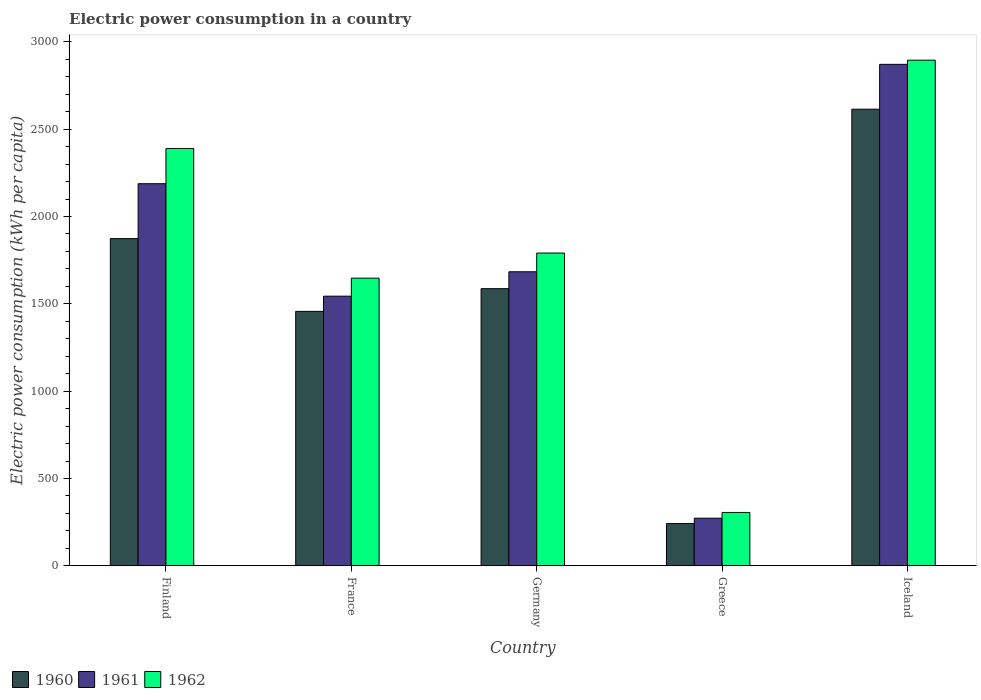How many groups of bars are there?
Offer a terse response. 5. Are the number of bars per tick equal to the number of legend labels?
Give a very brief answer. Yes. How many bars are there on the 4th tick from the right?
Keep it short and to the point. 3. What is the label of the 2nd group of bars from the left?
Give a very brief answer. France. In how many cases, is the number of bars for a given country not equal to the number of legend labels?
Your response must be concise. 0. What is the electric power consumption in in 1961 in Greece?
Your answer should be compact. 272.56. Across all countries, what is the maximum electric power consumption in in 1962?
Give a very brief answer. 2895.09. Across all countries, what is the minimum electric power consumption in in 1962?
Offer a terse response. 305.39. In which country was the electric power consumption in in 1960 maximum?
Keep it short and to the point. Iceland. In which country was the electric power consumption in in 1960 minimum?
Your answer should be compact. Greece. What is the total electric power consumption in in 1961 in the graph?
Offer a very short reply. 8558.36. What is the difference between the electric power consumption in in 1961 in Greece and that in Iceland?
Provide a short and direct response. -2598.48. What is the difference between the electric power consumption in in 1961 in France and the electric power consumption in in 1962 in Finland?
Keep it short and to the point. -845.5. What is the average electric power consumption in in 1962 per country?
Offer a very short reply. 1805.44. What is the difference between the electric power consumption in of/in 1961 and electric power consumption in of/in 1960 in Greece?
Your response must be concise. 30.84. What is the ratio of the electric power consumption in in 1961 in France to that in Germany?
Provide a succinct answer. 0.92. Is the electric power consumption in in 1961 in Germany less than that in Greece?
Make the answer very short. No. Is the difference between the electric power consumption in in 1961 in Germany and Iceland greater than the difference between the electric power consumption in in 1960 in Germany and Iceland?
Ensure brevity in your answer.  No. What is the difference between the highest and the second highest electric power consumption in in 1962?
Provide a succinct answer. 598.52. What is the difference between the highest and the lowest electric power consumption in in 1961?
Your answer should be compact. 2598.48. Is the sum of the electric power consumption in in 1962 in Greece and Iceland greater than the maximum electric power consumption in in 1960 across all countries?
Give a very brief answer. Yes. What does the 2nd bar from the right in Iceland represents?
Your response must be concise. 1961. How many bars are there?
Ensure brevity in your answer.  15. What is the difference between two consecutive major ticks on the Y-axis?
Your answer should be compact. 500. Does the graph contain any zero values?
Ensure brevity in your answer.  No. Does the graph contain grids?
Your answer should be compact. No. Where does the legend appear in the graph?
Your response must be concise. Bottom left. How many legend labels are there?
Provide a succinct answer. 3. How are the legend labels stacked?
Your response must be concise. Horizontal. What is the title of the graph?
Offer a terse response. Electric power consumption in a country. Does "1974" appear as one of the legend labels in the graph?
Provide a short and direct response. No. What is the label or title of the X-axis?
Keep it short and to the point. Country. What is the label or title of the Y-axis?
Your answer should be compact. Electric power consumption (kWh per capita). What is the Electric power consumption (kWh per capita) in 1960 in Finland?
Ensure brevity in your answer.  1873.29. What is the Electric power consumption (kWh per capita) in 1961 in Finland?
Your answer should be very brief. 2187.62. What is the Electric power consumption (kWh per capita) in 1962 in Finland?
Make the answer very short. 2389.21. What is the Electric power consumption (kWh per capita) of 1960 in France?
Provide a short and direct response. 1456.69. What is the Electric power consumption (kWh per capita) in 1961 in France?
Make the answer very short. 1543.71. What is the Electric power consumption (kWh per capita) in 1962 in France?
Provide a succinct answer. 1646.83. What is the Electric power consumption (kWh per capita) of 1960 in Germany?
Make the answer very short. 1586.75. What is the Electric power consumption (kWh per capita) of 1961 in Germany?
Provide a short and direct response. 1683.41. What is the Electric power consumption (kWh per capita) in 1962 in Germany?
Your response must be concise. 1790.69. What is the Electric power consumption (kWh per capita) in 1960 in Greece?
Your answer should be very brief. 241.73. What is the Electric power consumption (kWh per capita) in 1961 in Greece?
Your answer should be compact. 272.56. What is the Electric power consumption (kWh per capita) of 1962 in Greece?
Ensure brevity in your answer.  305.39. What is the Electric power consumption (kWh per capita) of 1960 in Iceland?
Give a very brief answer. 2614.28. What is the Electric power consumption (kWh per capita) of 1961 in Iceland?
Provide a succinct answer. 2871.04. What is the Electric power consumption (kWh per capita) of 1962 in Iceland?
Offer a terse response. 2895.09. Across all countries, what is the maximum Electric power consumption (kWh per capita) in 1960?
Provide a succinct answer. 2614.28. Across all countries, what is the maximum Electric power consumption (kWh per capita) in 1961?
Provide a short and direct response. 2871.04. Across all countries, what is the maximum Electric power consumption (kWh per capita) in 1962?
Give a very brief answer. 2895.09. Across all countries, what is the minimum Electric power consumption (kWh per capita) in 1960?
Offer a very short reply. 241.73. Across all countries, what is the minimum Electric power consumption (kWh per capita) of 1961?
Your answer should be very brief. 272.56. Across all countries, what is the minimum Electric power consumption (kWh per capita) of 1962?
Your answer should be very brief. 305.39. What is the total Electric power consumption (kWh per capita) of 1960 in the graph?
Offer a terse response. 7772.74. What is the total Electric power consumption (kWh per capita) of 1961 in the graph?
Your answer should be compact. 8558.36. What is the total Electric power consumption (kWh per capita) in 1962 in the graph?
Keep it short and to the point. 9027.2. What is the difference between the Electric power consumption (kWh per capita) in 1960 in Finland and that in France?
Provide a short and direct response. 416.6. What is the difference between the Electric power consumption (kWh per capita) in 1961 in Finland and that in France?
Ensure brevity in your answer.  643.91. What is the difference between the Electric power consumption (kWh per capita) of 1962 in Finland and that in France?
Your answer should be compact. 742.38. What is the difference between the Electric power consumption (kWh per capita) in 1960 in Finland and that in Germany?
Give a very brief answer. 286.54. What is the difference between the Electric power consumption (kWh per capita) of 1961 in Finland and that in Germany?
Keep it short and to the point. 504.21. What is the difference between the Electric power consumption (kWh per capita) in 1962 in Finland and that in Germany?
Offer a terse response. 598.52. What is the difference between the Electric power consumption (kWh per capita) in 1960 in Finland and that in Greece?
Your response must be concise. 1631.57. What is the difference between the Electric power consumption (kWh per capita) in 1961 in Finland and that in Greece?
Your response must be concise. 1915.06. What is the difference between the Electric power consumption (kWh per capita) of 1962 in Finland and that in Greece?
Your answer should be very brief. 2083.82. What is the difference between the Electric power consumption (kWh per capita) in 1960 in Finland and that in Iceland?
Keep it short and to the point. -740.99. What is the difference between the Electric power consumption (kWh per capita) of 1961 in Finland and that in Iceland?
Keep it short and to the point. -683.42. What is the difference between the Electric power consumption (kWh per capita) of 1962 in Finland and that in Iceland?
Your answer should be very brief. -505.88. What is the difference between the Electric power consumption (kWh per capita) in 1960 in France and that in Germany?
Keep it short and to the point. -130.06. What is the difference between the Electric power consumption (kWh per capita) of 1961 in France and that in Germany?
Offer a very short reply. -139.7. What is the difference between the Electric power consumption (kWh per capita) in 1962 in France and that in Germany?
Give a very brief answer. -143.85. What is the difference between the Electric power consumption (kWh per capita) in 1960 in France and that in Greece?
Your response must be concise. 1214.97. What is the difference between the Electric power consumption (kWh per capita) in 1961 in France and that in Greece?
Offer a very short reply. 1271.15. What is the difference between the Electric power consumption (kWh per capita) in 1962 in France and that in Greece?
Ensure brevity in your answer.  1341.44. What is the difference between the Electric power consumption (kWh per capita) of 1960 in France and that in Iceland?
Keep it short and to the point. -1157.59. What is the difference between the Electric power consumption (kWh per capita) of 1961 in France and that in Iceland?
Provide a short and direct response. -1327.33. What is the difference between the Electric power consumption (kWh per capita) of 1962 in France and that in Iceland?
Provide a short and direct response. -1248.25. What is the difference between the Electric power consumption (kWh per capita) of 1960 in Germany and that in Greece?
Offer a terse response. 1345.02. What is the difference between the Electric power consumption (kWh per capita) in 1961 in Germany and that in Greece?
Give a very brief answer. 1410.85. What is the difference between the Electric power consumption (kWh per capita) in 1962 in Germany and that in Greece?
Provide a short and direct response. 1485.3. What is the difference between the Electric power consumption (kWh per capita) of 1960 in Germany and that in Iceland?
Make the answer very short. -1027.53. What is the difference between the Electric power consumption (kWh per capita) of 1961 in Germany and that in Iceland?
Your response must be concise. -1187.63. What is the difference between the Electric power consumption (kWh per capita) in 1962 in Germany and that in Iceland?
Ensure brevity in your answer.  -1104.4. What is the difference between the Electric power consumption (kWh per capita) in 1960 in Greece and that in Iceland?
Make the answer very short. -2372.56. What is the difference between the Electric power consumption (kWh per capita) in 1961 in Greece and that in Iceland?
Your answer should be compact. -2598.48. What is the difference between the Electric power consumption (kWh per capita) in 1962 in Greece and that in Iceland?
Offer a very short reply. -2589.7. What is the difference between the Electric power consumption (kWh per capita) in 1960 in Finland and the Electric power consumption (kWh per capita) in 1961 in France?
Your answer should be compact. 329.58. What is the difference between the Electric power consumption (kWh per capita) in 1960 in Finland and the Electric power consumption (kWh per capita) in 1962 in France?
Ensure brevity in your answer.  226.46. What is the difference between the Electric power consumption (kWh per capita) of 1961 in Finland and the Electric power consumption (kWh per capita) of 1962 in France?
Provide a succinct answer. 540.79. What is the difference between the Electric power consumption (kWh per capita) in 1960 in Finland and the Electric power consumption (kWh per capita) in 1961 in Germany?
Offer a terse response. 189.88. What is the difference between the Electric power consumption (kWh per capita) in 1960 in Finland and the Electric power consumption (kWh per capita) in 1962 in Germany?
Provide a short and direct response. 82.61. What is the difference between the Electric power consumption (kWh per capita) of 1961 in Finland and the Electric power consumption (kWh per capita) of 1962 in Germany?
Keep it short and to the point. 396.94. What is the difference between the Electric power consumption (kWh per capita) of 1960 in Finland and the Electric power consumption (kWh per capita) of 1961 in Greece?
Ensure brevity in your answer.  1600.73. What is the difference between the Electric power consumption (kWh per capita) of 1960 in Finland and the Electric power consumption (kWh per capita) of 1962 in Greece?
Give a very brief answer. 1567.9. What is the difference between the Electric power consumption (kWh per capita) in 1961 in Finland and the Electric power consumption (kWh per capita) in 1962 in Greece?
Ensure brevity in your answer.  1882.23. What is the difference between the Electric power consumption (kWh per capita) in 1960 in Finland and the Electric power consumption (kWh per capita) in 1961 in Iceland?
Offer a very short reply. -997.75. What is the difference between the Electric power consumption (kWh per capita) of 1960 in Finland and the Electric power consumption (kWh per capita) of 1962 in Iceland?
Offer a terse response. -1021.79. What is the difference between the Electric power consumption (kWh per capita) in 1961 in Finland and the Electric power consumption (kWh per capita) in 1962 in Iceland?
Make the answer very short. -707.46. What is the difference between the Electric power consumption (kWh per capita) in 1960 in France and the Electric power consumption (kWh per capita) in 1961 in Germany?
Your answer should be very brief. -226.72. What is the difference between the Electric power consumption (kWh per capita) in 1960 in France and the Electric power consumption (kWh per capita) in 1962 in Germany?
Your answer should be very brief. -333.99. What is the difference between the Electric power consumption (kWh per capita) in 1961 in France and the Electric power consumption (kWh per capita) in 1962 in Germany?
Keep it short and to the point. -246.98. What is the difference between the Electric power consumption (kWh per capita) of 1960 in France and the Electric power consumption (kWh per capita) of 1961 in Greece?
Your answer should be compact. 1184.13. What is the difference between the Electric power consumption (kWh per capita) of 1960 in France and the Electric power consumption (kWh per capita) of 1962 in Greece?
Keep it short and to the point. 1151.3. What is the difference between the Electric power consumption (kWh per capita) in 1961 in France and the Electric power consumption (kWh per capita) in 1962 in Greece?
Give a very brief answer. 1238.32. What is the difference between the Electric power consumption (kWh per capita) of 1960 in France and the Electric power consumption (kWh per capita) of 1961 in Iceland?
Provide a succinct answer. -1414.35. What is the difference between the Electric power consumption (kWh per capita) of 1960 in France and the Electric power consumption (kWh per capita) of 1962 in Iceland?
Provide a succinct answer. -1438.39. What is the difference between the Electric power consumption (kWh per capita) in 1961 in France and the Electric power consumption (kWh per capita) in 1962 in Iceland?
Your answer should be very brief. -1351.37. What is the difference between the Electric power consumption (kWh per capita) in 1960 in Germany and the Electric power consumption (kWh per capita) in 1961 in Greece?
Your answer should be compact. 1314.19. What is the difference between the Electric power consumption (kWh per capita) in 1960 in Germany and the Electric power consumption (kWh per capita) in 1962 in Greece?
Give a very brief answer. 1281.36. What is the difference between the Electric power consumption (kWh per capita) of 1961 in Germany and the Electric power consumption (kWh per capita) of 1962 in Greece?
Provide a short and direct response. 1378.03. What is the difference between the Electric power consumption (kWh per capita) of 1960 in Germany and the Electric power consumption (kWh per capita) of 1961 in Iceland?
Make the answer very short. -1284.29. What is the difference between the Electric power consumption (kWh per capita) of 1960 in Germany and the Electric power consumption (kWh per capita) of 1962 in Iceland?
Make the answer very short. -1308.34. What is the difference between the Electric power consumption (kWh per capita) of 1961 in Germany and the Electric power consumption (kWh per capita) of 1962 in Iceland?
Your response must be concise. -1211.67. What is the difference between the Electric power consumption (kWh per capita) in 1960 in Greece and the Electric power consumption (kWh per capita) in 1961 in Iceland?
Offer a terse response. -2629.32. What is the difference between the Electric power consumption (kWh per capita) of 1960 in Greece and the Electric power consumption (kWh per capita) of 1962 in Iceland?
Provide a short and direct response. -2653.36. What is the difference between the Electric power consumption (kWh per capita) of 1961 in Greece and the Electric power consumption (kWh per capita) of 1962 in Iceland?
Keep it short and to the point. -2622.52. What is the average Electric power consumption (kWh per capita) in 1960 per country?
Give a very brief answer. 1554.55. What is the average Electric power consumption (kWh per capita) of 1961 per country?
Offer a terse response. 1711.67. What is the average Electric power consumption (kWh per capita) of 1962 per country?
Your response must be concise. 1805.44. What is the difference between the Electric power consumption (kWh per capita) of 1960 and Electric power consumption (kWh per capita) of 1961 in Finland?
Your response must be concise. -314.33. What is the difference between the Electric power consumption (kWh per capita) of 1960 and Electric power consumption (kWh per capita) of 1962 in Finland?
Offer a very short reply. -515.92. What is the difference between the Electric power consumption (kWh per capita) in 1961 and Electric power consumption (kWh per capita) in 1962 in Finland?
Your answer should be compact. -201.59. What is the difference between the Electric power consumption (kWh per capita) in 1960 and Electric power consumption (kWh per capita) in 1961 in France?
Your answer should be compact. -87.02. What is the difference between the Electric power consumption (kWh per capita) in 1960 and Electric power consumption (kWh per capita) in 1962 in France?
Offer a very short reply. -190.14. What is the difference between the Electric power consumption (kWh per capita) in 1961 and Electric power consumption (kWh per capita) in 1962 in France?
Offer a very short reply. -103.12. What is the difference between the Electric power consumption (kWh per capita) of 1960 and Electric power consumption (kWh per capita) of 1961 in Germany?
Provide a succinct answer. -96.67. What is the difference between the Electric power consumption (kWh per capita) of 1960 and Electric power consumption (kWh per capita) of 1962 in Germany?
Your answer should be very brief. -203.94. What is the difference between the Electric power consumption (kWh per capita) in 1961 and Electric power consumption (kWh per capita) in 1962 in Germany?
Ensure brevity in your answer.  -107.27. What is the difference between the Electric power consumption (kWh per capita) of 1960 and Electric power consumption (kWh per capita) of 1961 in Greece?
Make the answer very short. -30.84. What is the difference between the Electric power consumption (kWh per capita) in 1960 and Electric power consumption (kWh per capita) in 1962 in Greece?
Offer a terse response. -63.66. What is the difference between the Electric power consumption (kWh per capita) of 1961 and Electric power consumption (kWh per capita) of 1962 in Greece?
Your answer should be compact. -32.83. What is the difference between the Electric power consumption (kWh per capita) of 1960 and Electric power consumption (kWh per capita) of 1961 in Iceland?
Provide a short and direct response. -256.76. What is the difference between the Electric power consumption (kWh per capita) of 1960 and Electric power consumption (kWh per capita) of 1962 in Iceland?
Your answer should be very brief. -280.8. What is the difference between the Electric power consumption (kWh per capita) in 1961 and Electric power consumption (kWh per capita) in 1962 in Iceland?
Offer a terse response. -24.04. What is the ratio of the Electric power consumption (kWh per capita) in 1960 in Finland to that in France?
Give a very brief answer. 1.29. What is the ratio of the Electric power consumption (kWh per capita) in 1961 in Finland to that in France?
Make the answer very short. 1.42. What is the ratio of the Electric power consumption (kWh per capita) in 1962 in Finland to that in France?
Offer a terse response. 1.45. What is the ratio of the Electric power consumption (kWh per capita) in 1960 in Finland to that in Germany?
Your answer should be very brief. 1.18. What is the ratio of the Electric power consumption (kWh per capita) in 1961 in Finland to that in Germany?
Your answer should be compact. 1.3. What is the ratio of the Electric power consumption (kWh per capita) of 1962 in Finland to that in Germany?
Offer a very short reply. 1.33. What is the ratio of the Electric power consumption (kWh per capita) in 1960 in Finland to that in Greece?
Give a very brief answer. 7.75. What is the ratio of the Electric power consumption (kWh per capita) in 1961 in Finland to that in Greece?
Your answer should be very brief. 8.03. What is the ratio of the Electric power consumption (kWh per capita) of 1962 in Finland to that in Greece?
Your answer should be compact. 7.82. What is the ratio of the Electric power consumption (kWh per capita) of 1960 in Finland to that in Iceland?
Offer a very short reply. 0.72. What is the ratio of the Electric power consumption (kWh per capita) of 1961 in Finland to that in Iceland?
Offer a very short reply. 0.76. What is the ratio of the Electric power consumption (kWh per capita) of 1962 in Finland to that in Iceland?
Provide a short and direct response. 0.83. What is the ratio of the Electric power consumption (kWh per capita) of 1960 in France to that in Germany?
Provide a succinct answer. 0.92. What is the ratio of the Electric power consumption (kWh per capita) in 1961 in France to that in Germany?
Offer a very short reply. 0.92. What is the ratio of the Electric power consumption (kWh per capita) in 1962 in France to that in Germany?
Keep it short and to the point. 0.92. What is the ratio of the Electric power consumption (kWh per capita) of 1960 in France to that in Greece?
Give a very brief answer. 6.03. What is the ratio of the Electric power consumption (kWh per capita) in 1961 in France to that in Greece?
Make the answer very short. 5.66. What is the ratio of the Electric power consumption (kWh per capita) of 1962 in France to that in Greece?
Provide a succinct answer. 5.39. What is the ratio of the Electric power consumption (kWh per capita) in 1960 in France to that in Iceland?
Provide a succinct answer. 0.56. What is the ratio of the Electric power consumption (kWh per capita) in 1961 in France to that in Iceland?
Provide a short and direct response. 0.54. What is the ratio of the Electric power consumption (kWh per capita) in 1962 in France to that in Iceland?
Ensure brevity in your answer.  0.57. What is the ratio of the Electric power consumption (kWh per capita) of 1960 in Germany to that in Greece?
Make the answer very short. 6.56. What is the ratio of the Electric power consumption (kWh per capita) of 1961 in Germany to that in Greece?
Your answer should be very brief. 6.18. What is the ratio of the Electric power consumption (kWh per capita) in 1962 in Germany to that in Greece?
Your answer should be compact. 5.86. What is the ratio of the Electric power consumption (kWh per capita) of 1960 in Germany to that in Iceland?
Offer a very short reply. 0.61. What is the ratio of the Electric power consumption (kWh per capita) of 1961 in Germany to that in Iceland?
Offer a terse response. 0.59. What is the ratio of the Electric power consumption (kWh per capita) in 1962 in Germany to that in Iceland?
Your answer should be very brief. 0.62. What is the ratio of the Electric power consumption (kWh per capita) in 1960 in Greece to that in Iceland?
Make the answer very short. 0.09. What is the ratio of the Electric power consumption (kWh per capita) of 1961 in Greece to that in Iceland?
Your answer should be compact. 0.09. What is the ratio of the Electric power consumption (kWh per capita) in 1962 in Greece to that in Iceland?
Offer a terse response. 0.11. What is the difference between the highest and the second highest Electric power consumption (kWh per capita) in 1960?
Give a very brief answer. 740.99. What is the difference between the highest and the second highest Electric power consumption (kWh per capita) in 1961?
Offer a terse response. 683.42. What is the difference between the highest and the second highest Electric power consumption (kWh per capita) in 1962?
Offer a very short reply. 505.88. What is the difference between the highest and the lowest Electric power consumption (kWh per capita) of 1960?
Provide a short and direct response. 2372.56. What is the difference between the highest and the lowest Electric power consumption (kWh per capita) in 1961?
Your response must be concise. 2598.48. What is the difference between the highest and the lowest Electric power consumption (kWh per capita) in 1962?
Your answer should be compact. 2589.7. 